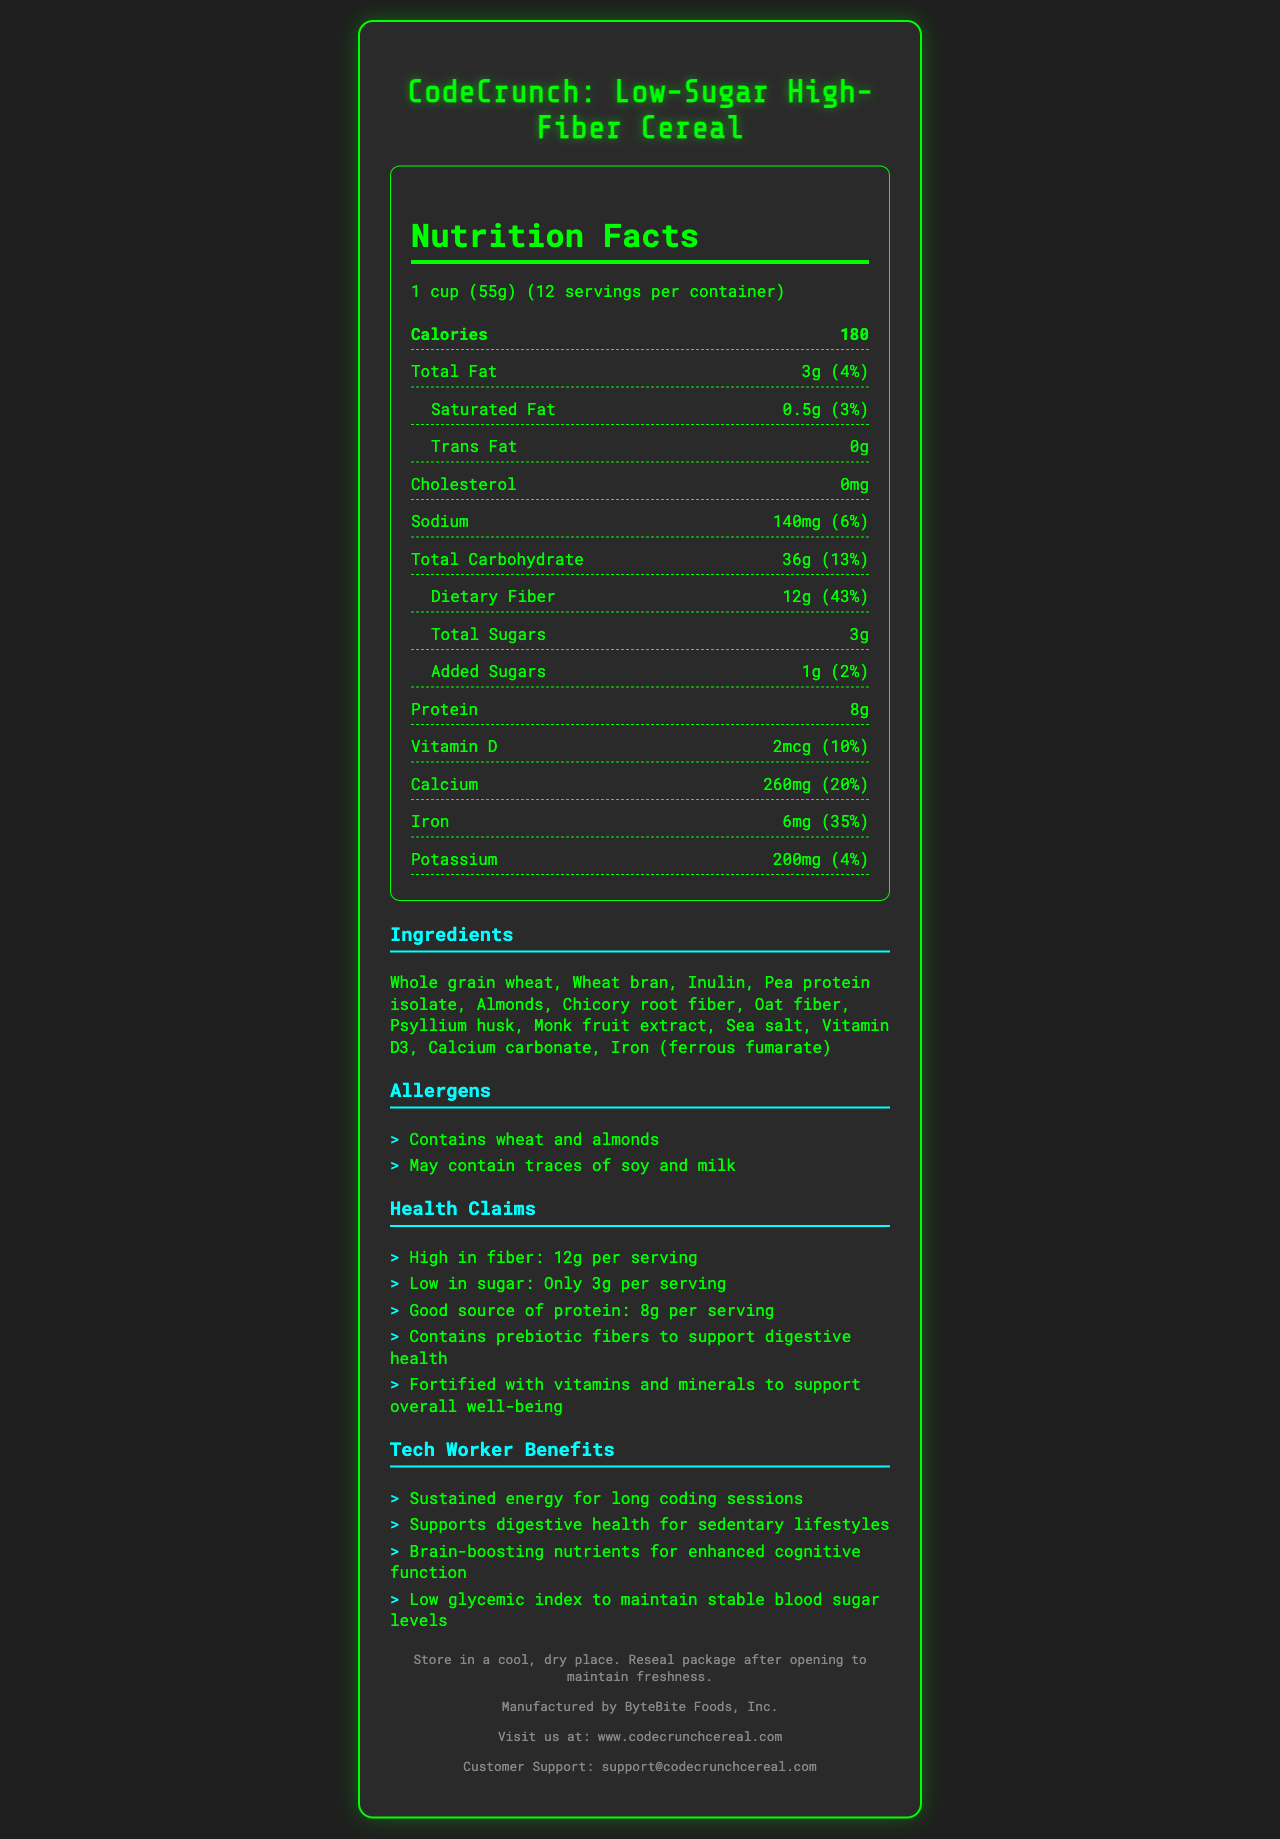what is the serving size for CodeCrunch: Low-Sugar High-Fiber Cereal? The serving size is listed at the top of the nutrition facts section of the document.
Answer: 1 cup (55g) how many servings are in one container? The document states that there are 12 servings per container.
Answer: 12 what is the total fat content per serving? The total fat content is listed in the nutrition facts section as 3g per serving.
Answer: 3g how many grams of dietary fiber are in each serving? The dietary fiber content per serving is shown as 12g in the nutrition facts section.
Answer: 12g how much protein does one serving provide? The protein content per serving is listed as 8g in the nutrition facts section.
Answer: 8g which ingredient is used as a sweetener in the cereal? Monk fruit extract is listed among the ingredients and known for its use as a natural sweetener.
Answer: Monk fruit extract does the cereal contain any trans fat? The nutrition facts indicate that the cereal contains 0g of trans fat.
Answer: No how is the cereal beneficial for tech workers? The document lists several benefits specifically for tech workers, such as sustained energy and brain-boosting nutrients.
Answer: Sustained energy for long coding sessions, supports digestive health, brain-boosting nutrients, low glycemic index how much calcium is in each serving? A. 100mg B. 200mg C. 260mg D. 300mg The calcium content in each serving is 260mg, which is listed in the nutrition facts section.
Answer: C. 260mg which vitamins and minerals are included in the cereal? A. Vitamin D, Calcium, Iron B. Vitamin C, Calcium, Magnesium C. Vitamin A, Calcium, Zinc D. Vitamin B12, Calcium, Iron The nutrition facts section includes Vitamin D, Calcium, and Iron.
Answer: A. Vitamin D, Calcium, Iron is the cereal suitable for people with a soy allergy? The allergen warning section includes "May contain traces of soy."
Answer: It may not be safe describe the main benefits of CodeCrunch cereal for tech workers The document highlights that the cereal offers sustained energy, supports digestive health, provides brain-boosting nutrients, and has a low glycemic index, all of which are beneficial for tech workers.
Answer: The cereal is formulated to support energy levels, digestive health, and cognitive function while maintaining stable blood sugar levels. what is the storage instruction for maintaining the freshness of the cereal? The storage instructions are listed at the bottom of the document.
Answer: Store in a cool, dry place. Reseal package after opening to maintain freshness. what specific prebiotic fibers are mentioned to support digestive health? The document mentions prebiotic fibers but does not specify which particular prebiotic fibers are included.
Answer: Cannot be determined who manufactures the cereal? The manufacturer information is provided at the bottom of the document.
Answer: ByteBite Foods, Inc. which vitamin in the cereal supports bone health? Vitamin D is known to support bone health, and it is listed in the nutrition facts section of the document.
Answer: Vitamin D how many grams of added sugars are in each serving? The added sugars per serving are listed as 1g in the nutrition facts section.
Answer: 1g which ingredients indicate the cereal is high in fiber? Select all that apply: A. Whole grain wheat B. Wheat bran C. Chicory root fiber D. Psyllium husk E. Monk fruit extract Whole grain wheat, wheat bran, chicory root fiber, and psyllium husk are high in fiber, as indicated by their inclusion in the ingredient list.
Answer: A, B, C, D what is the website where more information about the cereal can be found? The website for more information is provided at the bottom of the document.
Answer: www.codecrunchcereal.com what health claim is made about sugar content in the cereal? One of the health claims listed in the document is that the cereal is low in sugar with only 3g per serving.
Answer: Low in sugar: Only 3g per serving 